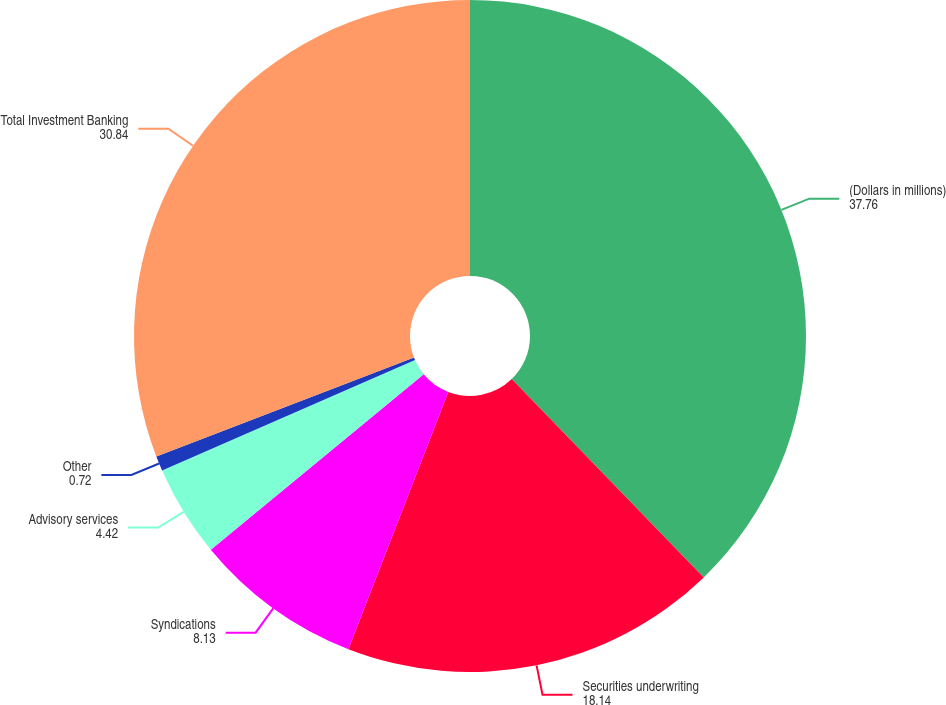Convert chart. <chart><loc_0><loc_0><loc_500><loc_500><pie_chart><fcel>(Dollars in millions)<fcel>Securities underwriting<fcel>Syndications<fcel>Advisory services<fcel>Other<fcel>Total Investment Banking<nl><fcel>37.76%<fcel>18.14%<fcel>8.13%<fcel>4.42%<fcel>0.72%<fcel>30.84%<nl></chart> 